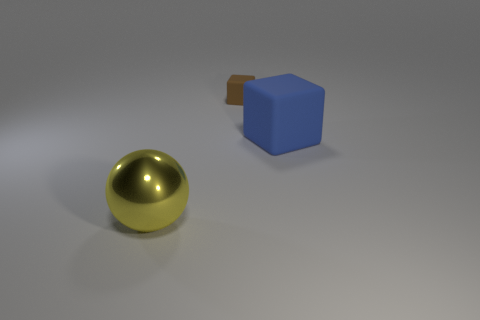Add 3 big purple matte things. How many objects exist? 6 Subtract all blocks. How many objects are left? 1 Add 3 big rubber blocks. How many big rubber blocks are left? 4 Add 1 gray rubber things. How many gray rubber things exist? 1 Subtract 0 green blocks. How many objects are left? 3 Subtract all purple shiny cubes. Subtract all large blue rubber cubes. How many objects are left? 2 